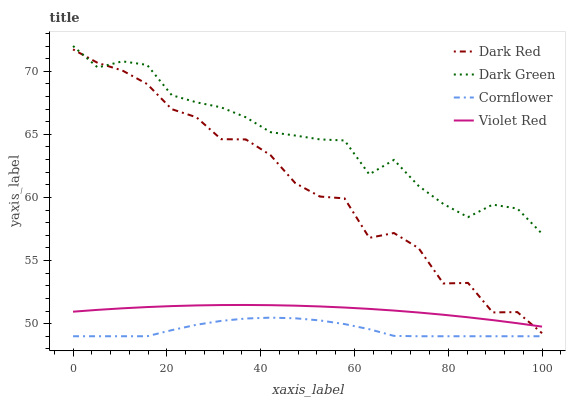Does Cornflower have the minimum area under the curve?
Answer yes or no. Yes. Does Dark Green have the maximum area under the curve?
Answer yes or no. Yes. Does Violet Red have the minimum area under the curve?
Answer yes or no. No. Does Violet Red have the maximum area under the curve?
Answer yes or no. No. Is Violet Red the smoothest?
Answer yes or no. Yes. Is Dark Red the roughest?
Answer yes or no. Yes. Is Cornflower the smoothest?
Answer yes or no. No. Is Cornflower the roughest?
Answer yes or no. No. Does Cornflower have the lowest value?
Answer yes or no. Yes. Does Violet Red have the lowest value?
Answer yes or no. No. Does Dark Green have the highest value?
Answer yes or no. Yes. Does Violet Red have the highest value?
Answer yes or no. No. Is Cornflower less than Violet Red?
Answer yes or no. Yes. Is Dark Red greater than Cornflower?
Answer yes or no. Yes. Does Dark Green intersect Dark Red?
Answer yes or no. Yes. Is Dark Green less than Dark Red?
Answer yes or no. No. Is Dark Green greater than Dark Red?
Answer yes or no. No. Does Cornflower intersect Violet Red?
Answer yes or no. No. 